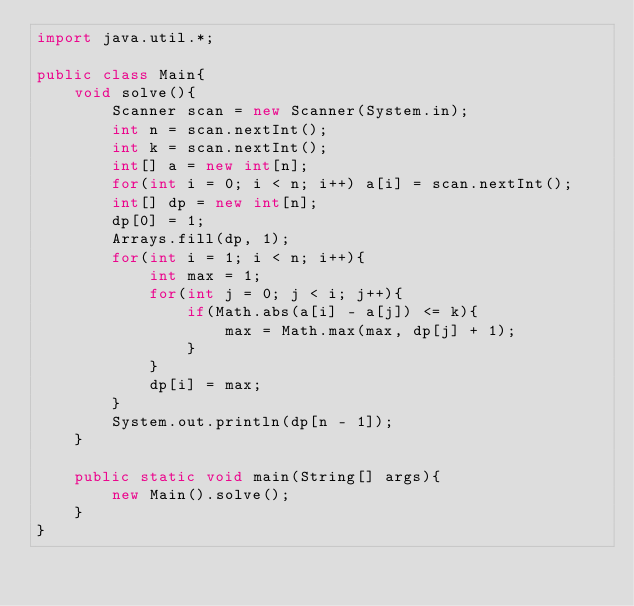<code> <loc_0><loc_0><loc_500><loc_500><_Java_>import java.util.*;

public class Main{
    void solve(){
        Scanner scan = new Scanner(System.in);
        int n = scan.nextInt();
        int k = scan.nextInt();
        int[] a = new int[n];
        for(int i = 0; i < n; i++) a[i] = scan.nextInt();
        int[] dp = new int[n];
        dp[0] = 1;
        Arrays.fill(dp, 1);
        for(int i = 1; i < n; i++){
            int max = 1;
            for(int j = 0; j < i; j++){
                if(Math.abs(a[i] - a[j]) <= k){
                    max = Math.max(max, dp[j] + 1);
                }
            }
            dp[i] = max;
        }
        System.out.println(dp[n - 1]);
    }

    public static void main(String[] args){
        new Main().solve();
    }
}
</code> 